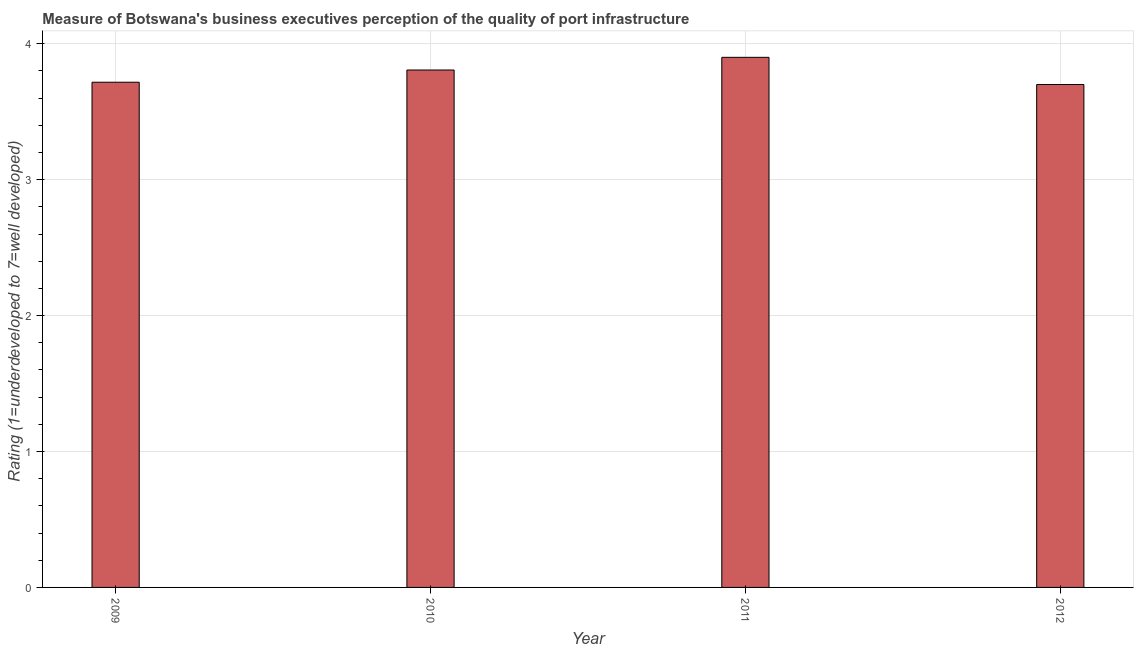Does the graph contain grids?
Your answer should be compact. Yes. What is the title of the graph?
Give a very brief answer. Measure of Botswana's business executives perception of the quality of port infrastructure. What is the label or title of the Y-axis?
Provide a succinct answer. Rating (1=underdeveloped to 7=well developed) . In which year was the rating measuring quality of port infrastructure maximum?
Give a very brief answer. 2011. What is the sum of the rating measuring quality of port infrastructure?
Your response must be concise. 15.12. What is the difference between the rating measuring quality of port infrastructure in 2011 and 2012?
Ensure brevity in your answer.  0.2. What is the average rating measuring quality of port infrastructure per year?
Offer a terse response. 3.78. What is the median rating measuring quality of port infrastructure?
Provide a succinct answer. 3.76. In how many years, is the rating measuring quality of port infrastructure greater than 1.6 ?
Your answer should be compact. 4. Do a majority of the years between 2011 and 2010 (inclusive) have rating measuring quality of port infrastructure greater than 1.6 ?
Your response must be concise. No. What is the ratio of the rating measuring quality of port infrastructure in 2009 to that in 2011?
Provide a succinct answer. 0.95. Is the rating measuring quality of port infrastructure in 2009 less than that in 2011?
Provide a short and direct response. Yes. What is the difference between the highest and the second highest rating measuring quality of port infrastructure?
Your answer should be compact. 0.09. What is the difference between the highest and the lowest rating measuring quality of port infrastructure?
Ensure brevity in your answer.  0.2. In how many years, is the rating measuring quality of port infrastructure greater than the average rating measuring quality of port infrastructure taken over all years?
Your answer should be compact. 2. How many years are there in the graph?
Keep it short and to the point. 4. What is the difference between two consecutive major ticks on the Y-axis?
Provide a short and direct response. 1. Are the values on the major ticks of Y-axis written in scientific E-notation?
Ensure brevity in your answer.  No. What is the Rating (1=underdeveloped to 7=well developed)  of 2009?
Give a very brief answer. 3.72. What is the Rating (1=underdeveloped to 7=well developed)  of 2010?
Make the answer very short. 3.81. What is the Rating (1=underdeveloped to 7=well developed)  in 2011?
Your answer should be compact. 3.9. What is the difference between the Rating (1=underdeveloped to 7=well developed)  in 2009 and 2010?
Offer a very short reply. -0.09. What is the difference between the Rating (1=underdeveloped to 7=well developed)  in 2009 and 2011?
Ensure brevity in your answer.  -0.18. What is the difference between the Rating (1=underdeveloped to 7=well developed)  in 2009 and 2012?
Ensure brevity in your answer.  0.02. What is the difference between the Rating (1=underdeveloped to 7=well developed)  in 2010 and 2011?
Provide a short and direct response. -0.09. What is the difference between the Rating (1=underdeveloped to 7=well developed)  in 2010 and 2012?
Provide a succinct answer. 0.11. What is the difference between the Rating (1=underdeveloped to 7=well developed)  in 2011 and 2012?
Offer a very short reply. 0.2. What is the ratio of the Rating (1=underdeveloped to 7=well developed)  in 2009 to that in 2010?
Your answer should be very brief. 0.98. What is the ratio of the Rating (1=underdeveloped to 7=well developed)  in 2009 to that in 2011?
Your response must be concise. 0.95. What is the ratio of the Rating (1=underdeveloped to 7=well developed)  in 2009 to that in 2012?
Offer a very short reply. 1. What is the ratio of the Rating (1=underdeveloped to 7=well developed)  in 2010 to that in 2012?
Make the answer very short. 1.03. What is the ratio of the Rating (1=underdeveloped to 7=well developed)  in 2011 to that in 2012?
Your response must be concise. 1.05. 